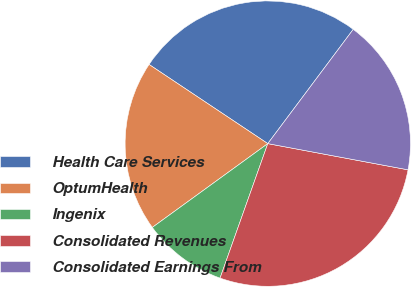<chart> <loc_0><loc_0><loc_500><loc_500><pie_chart><fcel>Health Care Services<fcel>OptumHealth<fcel>Ingenix<fcel>Consolidated Revenues<fcel>Consolidated Earnings From<nl><fcel>25.86%<fcel>19.35%<fcel>9.58%<fcel>27.49%<fcel>17.72%<nl></chart> 